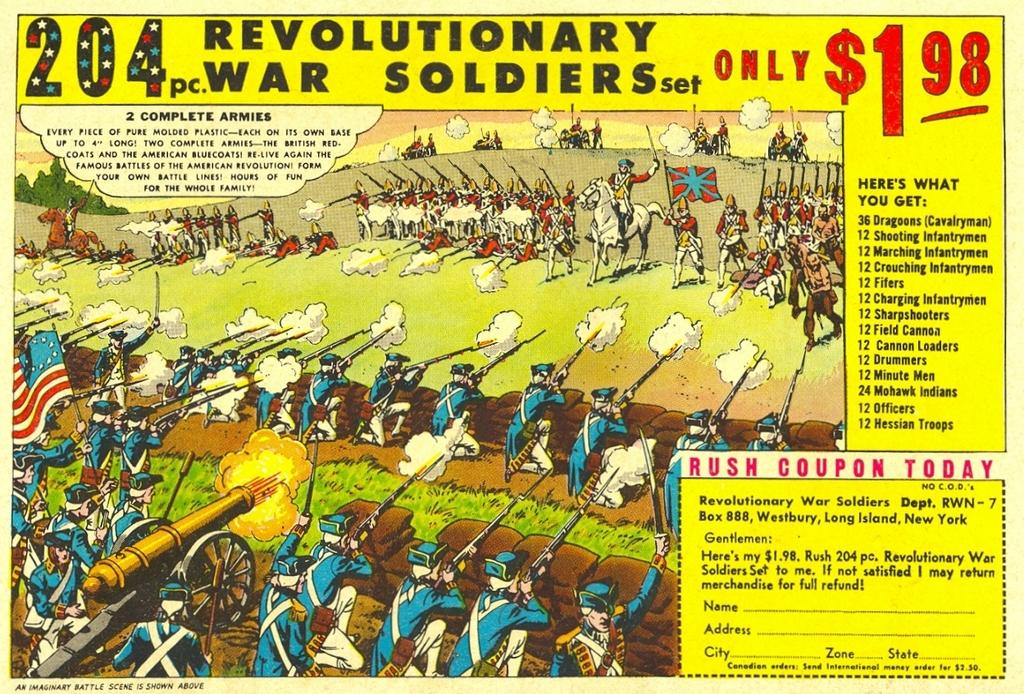<image>
Offer a succinct explanation of the picture presented. A box of Revolutionary war soldiers set of 204 pieces. 